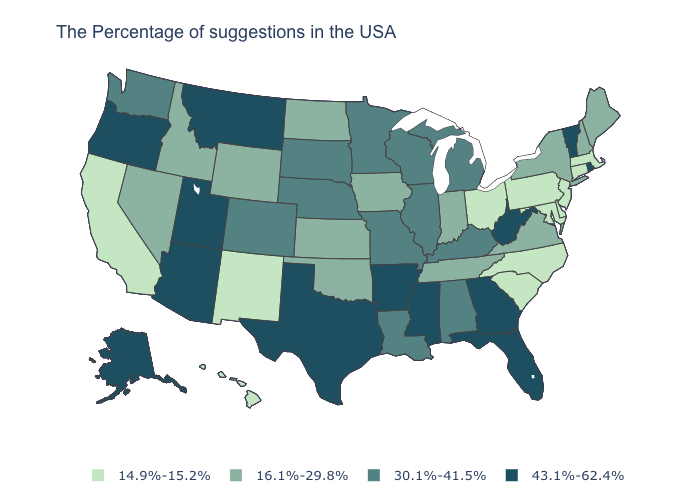Name the states that have a value in the range 43.1%-62.4%?
Be succinct. Rhode Island, Vermont, West Virginia, Florida, Georgia, Mississippi, Arkansas, Texas, Utah, Montana, Arizona, Oregon, Alaska. What is the value of Delaware?
Be succinct. 14.9%-15.2%. Does Georgia have the highest value in the USA?
Be succinct. Yes. How many symbols are there in the legend?
Be succinct. 4. Name the states that have a value in the range 16.1%-29.8%?
Keep it brief. Maine, New Hampshire, New York, Virginia, Indiana, Tennessee, Iowa, Kansas, Oklahoma, North Dakota, Wyoming, Idaho, Nevada. Name the states that have a value in the range 14.9%-15.2%?
Give a very brief answer. Massachusetts, Connecticut, New Jersey, Delaware, Maryland, Pennsylvania, North Carolina, South Carolina, Ohio, New Mexico, California, Hawaii. Name the states that have a value in the range 43.1%-62.4%?
Give a very brief answer. Rhode Island, Vermont, West Virginia, Florida, Georgia, Mississippi, Arkansas, Texas, Utah, Montana, Arizona, Oregon, Alaska. What is the value of North Carolina?
Write a very short answer. 14.9%-15.2%. Does the first symbol in the legend represent the smallest category?
Be succinct. Yes. Does Ohio have the lowest value in the USA?
Answer briefly. Yes. Which states hav the highest value in the MidWest?
Give a very brief answer. Michigan, Wisconsin, Illinois, Missouri, Minnesota, Nebraska, South Dakota. Among the states that border Oregon , does California have the lowest value?
Write a very short answer. Yes. What is the value of Indiana?
Be succinct. 16.1%-29.8%. 